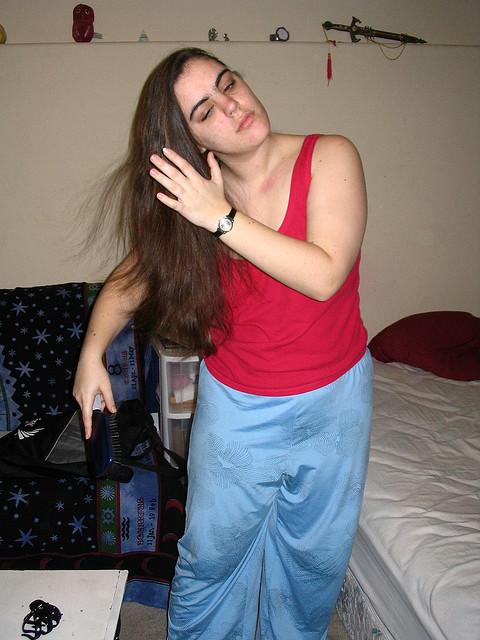Is she brushing her hair?
Quick response, please. Yes. Does this woman look happy?
Be succinct. No. What does the bed need?
Concise answer only. Sheets. Does she enjoy brushing her hair?
Quick response, please. Yes. What color shirt is she wearing?
Write a very short answer. Red. Is this lady getting ready to go clubbing?
Concise answer only. No. 